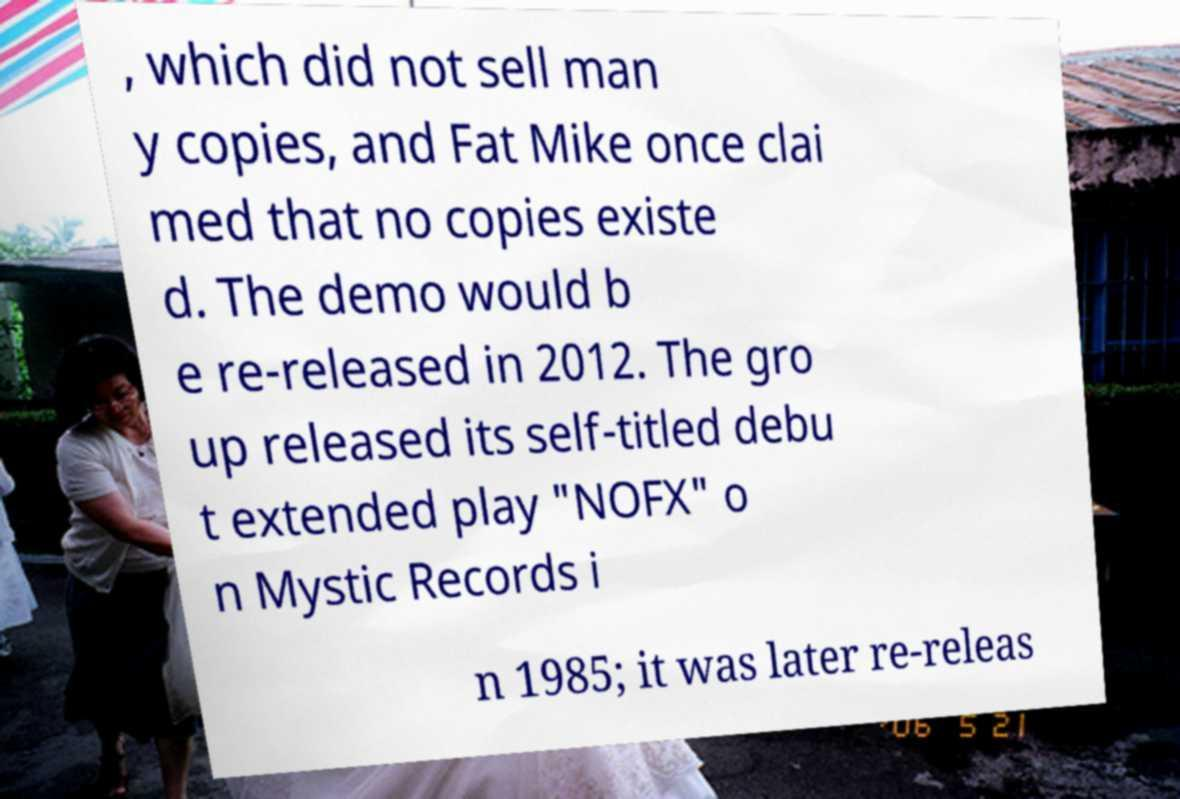Could you extract and type out the text from this image? , which did not sell man y copies, and Fat Mike once clai med that no copies existe d. The demo would b e re-released in 2012. The gro up released its self-titled debu t extended play "NOFX" o n Mystic Records i n 1985; it was later re-releas 